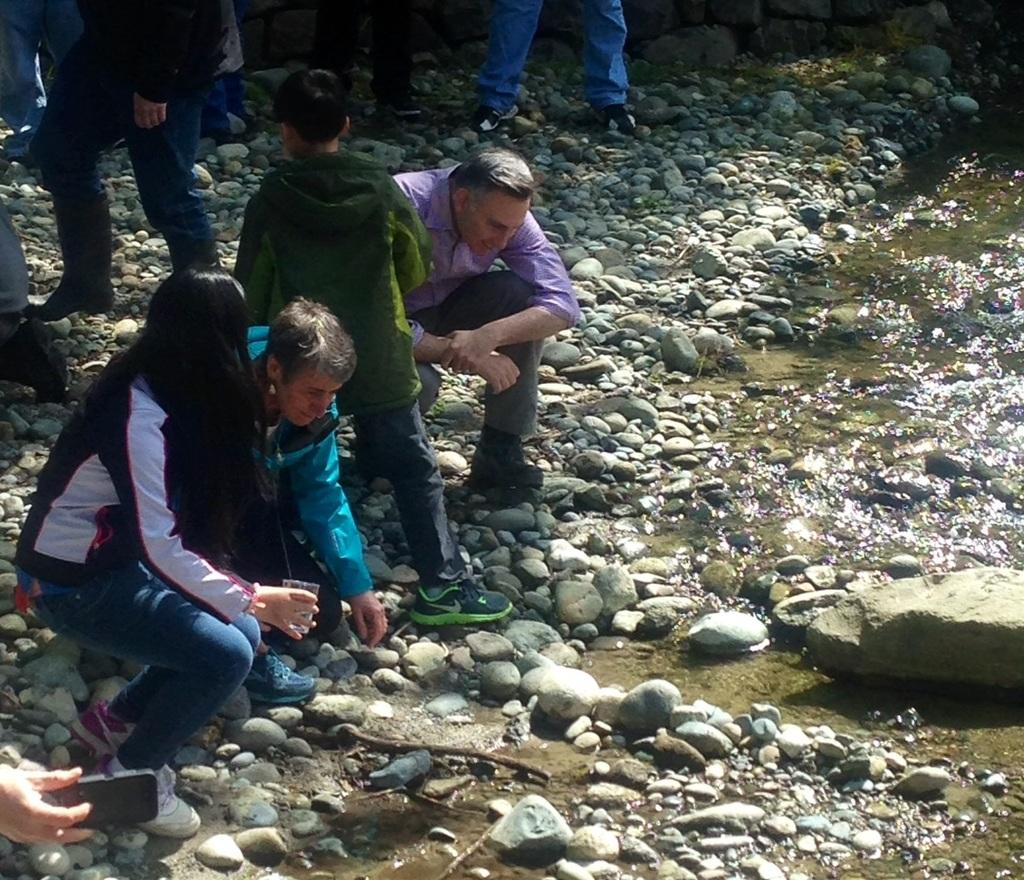What can be seen on the left side of the image? There are people on the left side of the image. Can you describe the positions of the people in the image? Some people are sitting, while others are standing. What is visible on the right side of the image? There is water visible on the right side of the image. What type of surface is present on the right side of the image? Stones are present on the ground on the right side of the image. What is the distribution of scientific theories in the image? There is no mention of scientific theories in the image; it features people and a natural setting with water and stones. 